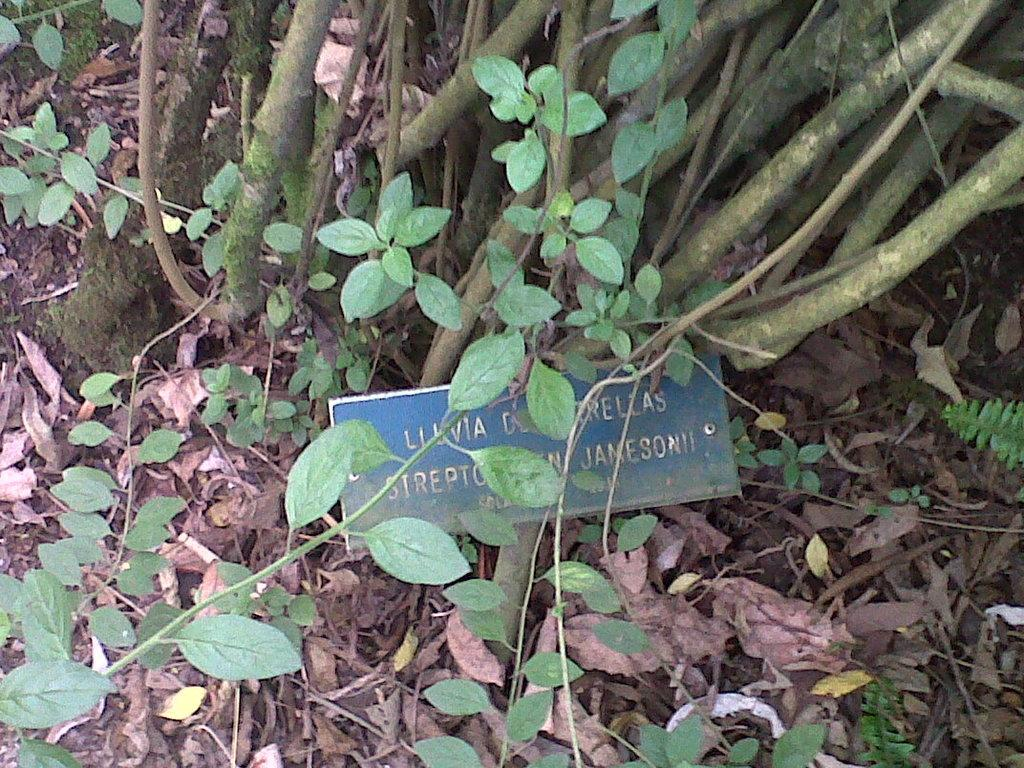What is on the ground in the image? There are leaves on the ground in the image. What type of vegetation is present in the image? There are plants in the image. What color are the plants? The plants are green in color. What is the color of the board in the image? There is a blue-colored board in the image. What type of drum can be seen in the image? There is no drum present in the image. What kind of beef is being prepared in the image? There is no beef or any food preparation visible in the image. 